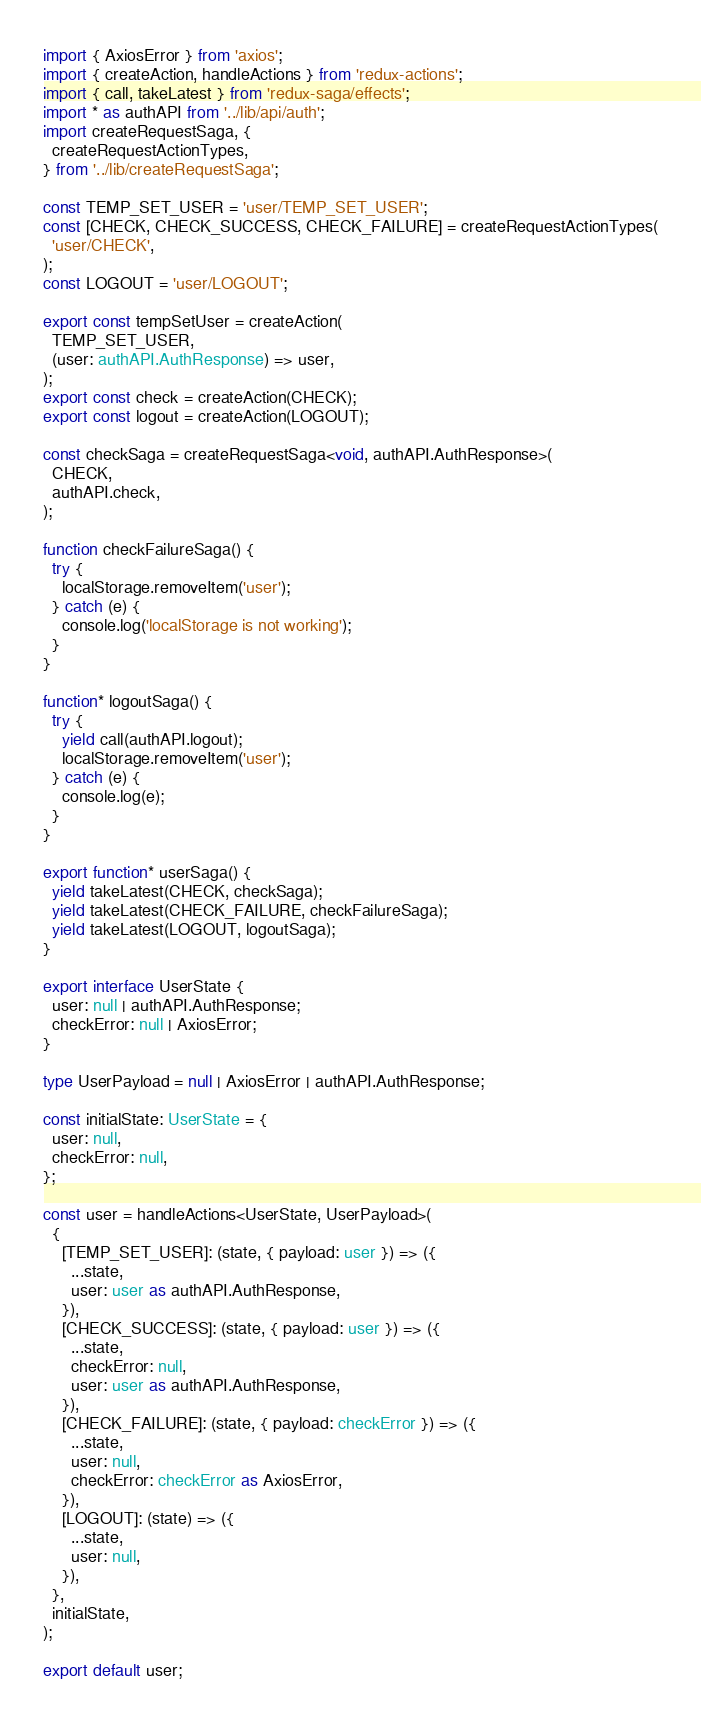Convert code to text. <code><loc_0><loc_0><loc_500><loc_500><_TypeScript_>import { AxiosError } from 'axios';
import { createAction, handleActions } from 'redux-actions';
import { call, takeLatest } from 'redux-saga/effects';
import * as authAPI from '../lib/api/auth';
import createRequestSaga, {
  createRequestActionTypes,
} from '../lib/createRequestSaga';

const TEMP_SET_USER = 'user/TEMP_SET_USER';
const [CHECK, CHECK_SUCCESS, CHECK_FAILURE] = createRequestActionTypes(
  'user/CHECK',
);
const LOGOUT = 'user/LOGOUT';

export const tempSetUser = createAction(
  TEMP_SET_USER,
  (user: authAPI.AuthResponse) => user,
);
export const check = createAction(CHECK);
export const logout = createAction(LOGOUT);

const checkSaga = createRequestSaga<void, authAPI.AuthResponse>(
  CHECK,
  authAPI.check,
);

function checkFailureSaga() {
  try {
    localStorage.removeItem('user');
  } catch (e) {
    console.log('localStorage is not working');
  }
}

function* logoutSaga() {
  try {
    yield call(authAPI.logout);
    localStorage.removeItem('user');
  } catch (e) {
    console.log(e);
  }
}

export function* userSaga() {
  yield takeLatest(CHECK, checkSaga);
  yield takeLatest(CHECK_FAILURE, checkFailureSaga);
  yield takeLatest(LOGOUT, logoutSaga);
}

export interface UserState {
  user: null | authAPI.AuthResponse;
  checkError: null | AxiosError;
}

type UserPayload = null | AxiosError | authAPI.AuthResponse;

const initialState: UserState = {
  user: null,
  checkError: null,
};

const user = handleActions<UserState, UserPayload>(
  {
    [TEMP_SET_USER]: (state, { payload: user }) => ({
      ...state,
      user: user as authAPI.AuthResponse,
    }),
    [CHECK_SUCCESS]: (state, { payload: user }) => ({
      ...state,
      checkError: null,
      user: user as authAPI.AuthResponse,
    }),
    [CHECK_FAILURE]: (state, { payload: checkError }) => ({
      ...state,
      user: null,
      checkError: checkError as AxiosError,
    }),
    [LOGOUT]: (state) => ({
      ...state,
      user: null,
    }),
  },
  initialState,
);

export default user;
</code> 